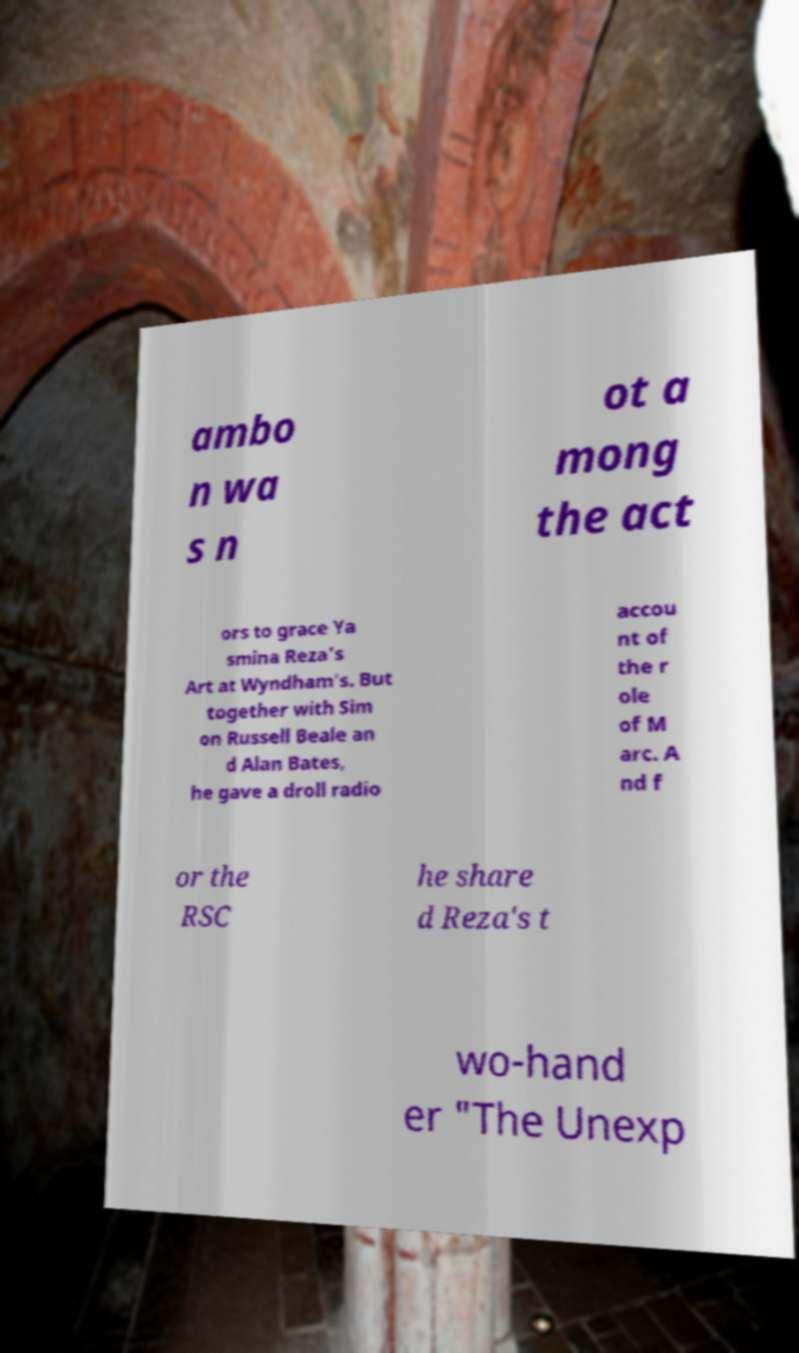Please read and relay the text visible in this image. What does it say? ambo n wa s n ot a mong the act ors to grace Ya smina Reza's Art at Wyndham's. But together with Sim on Russell Beale an d Alan Bates, he gave a droll radio accou nt of the r ole of M arc. A nd f or the RSC he share d Reza's t wo-hand er "The Unexp 